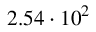<formula> <loc_0><loc_0><loc_500><loc_500>2 . 5 4 \cdot 1 0 ^ { 2 }</formula> 